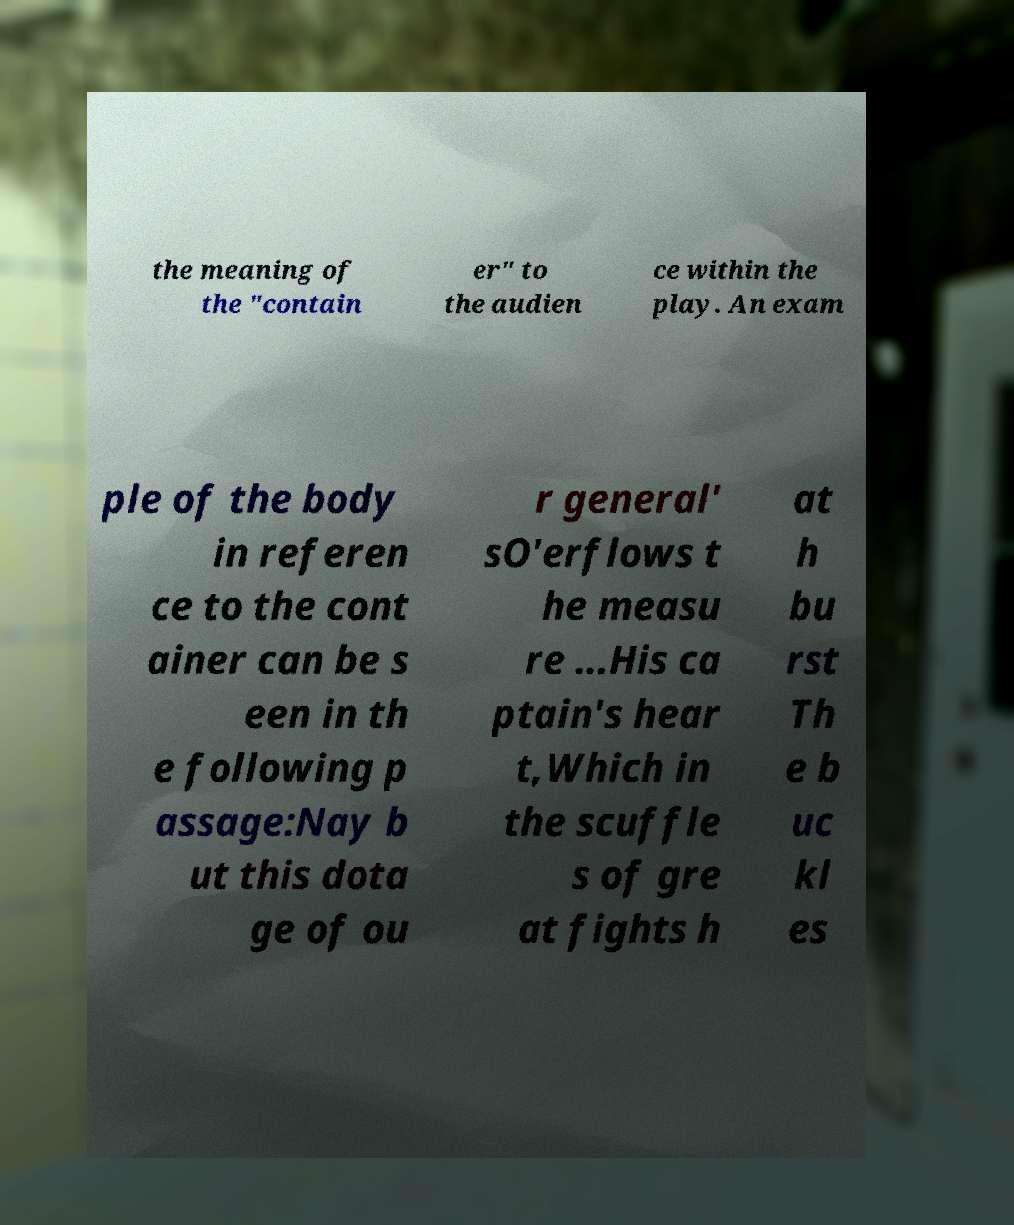There's text embedded in this image that I need extracted. Can you transcribe it verbatim? the meaning of the "contain er" to the audien ce within the play. An exam ple of the body in referen ce to the cont ainer can be s een in th e following p assage:Nay b ut this dota ge of ou r general' sO'erflows t he measu re ...His ca ptain's hear t,Which in the scuffle s of gre at fights h at h bu rst Th e b uc kl es 